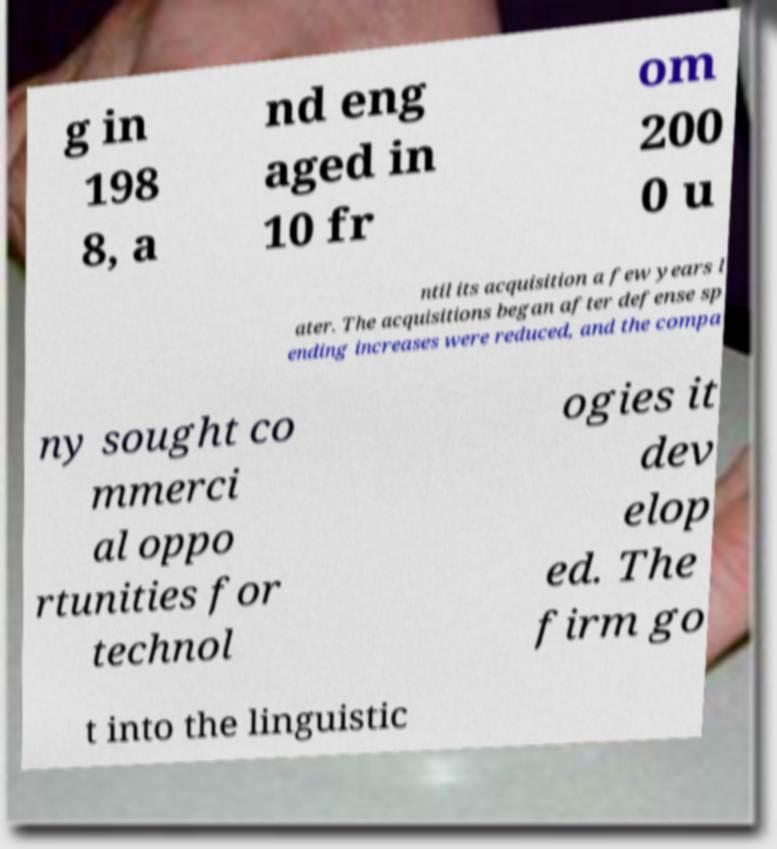What messages or text are displayed in this image? I need them in a readable, typed format. g in 198 8, a nd eng aged in 10 fr om 200 0 u ntil its acquisition a few years l ater. The acquisitions began after defense sp ending increases were reduced, and the compa ny sought co mmerci al oppo rtunities for technol ogies it dev elop ed. The firm go t into the linguistic 